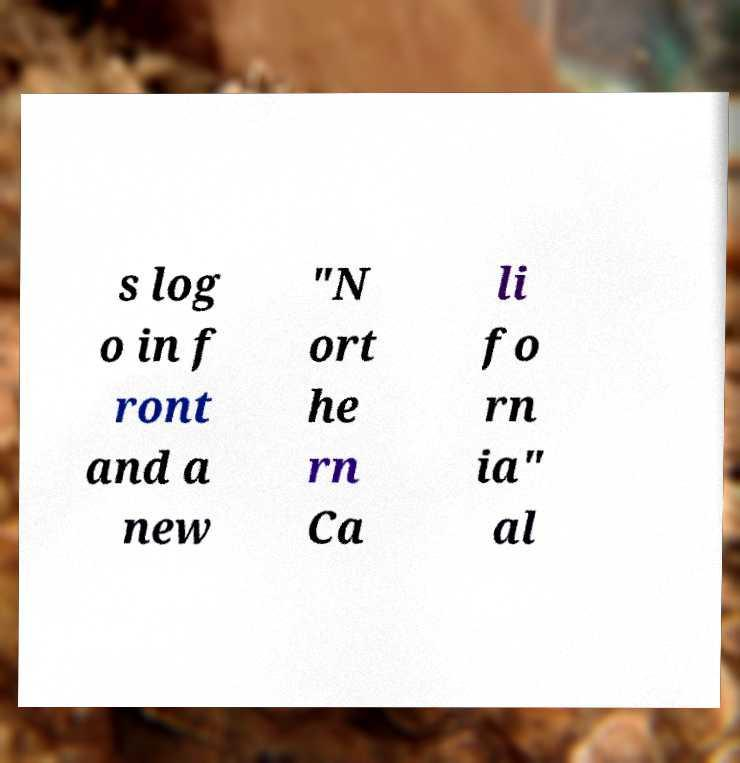Please identify and transcribe the text found in this image. s log o in f ront and a new "N ort he rn Ca li fo rn ia" al 